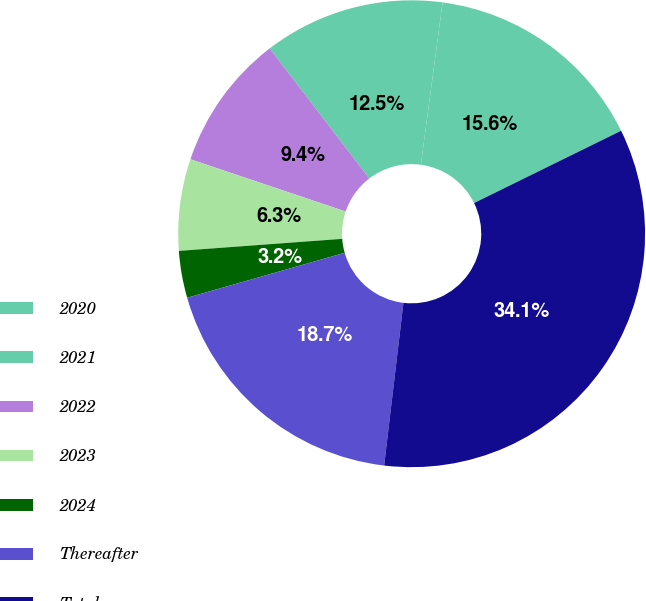Convert chart. <chart><loc_0><loc_0><loc_500><loc_500><pie_chart><fcel>2020<fcel>2021<fcel>2022<fcel>2023<fcel>2024<fcel>Thereafter<fcel>Total<nl><fcel>15.61%<fcel>12.52%<fcel>9.43%<fcel>6.34%<fcel>3.25%<fcel>18.7%<fcel>34.15%<nl></chart> 